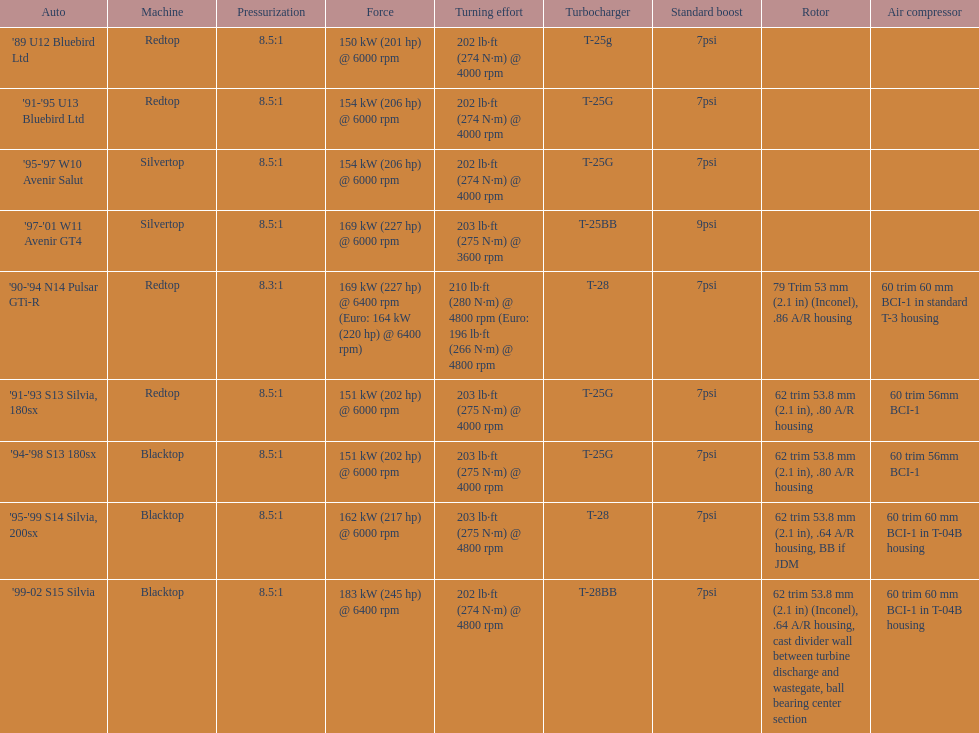Which engines are the same as the first entry ('89 u12 bluebird ltd)? '91-'95 U13 Bluebird Ltd, '90-'94 N14 Pulsar GTi-R, '91-'93 S13 Silvia, 180sx. 